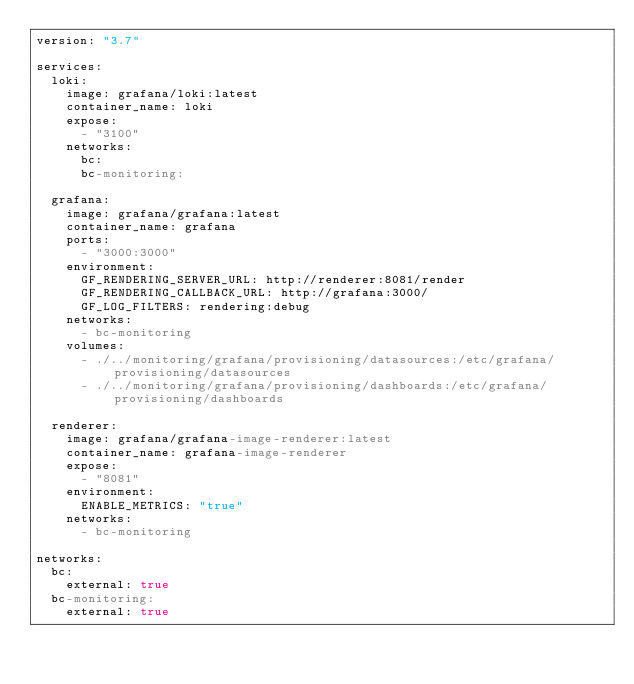Convert code to text. <code><loc_0><loc_0><loc_500><loc_500><_YAML_>version: "3.7"

services:
  loki:
    image: grafana/loki:latest
    container_name: loki
    expose:
      - "3100"
    networks:
      bc:
      bc-monitoring:

  grafana:
    image: grafana/grafana:latest
    container_name: grafana
    ports:
      - "3000:3000"
    environment:
      GF_RENDERING_SERVER_URL: http://renderer:8081/render
      GF_RENDERING_CALLBACK_URL: http://grafana:3000/
      GF_LOG_FILTERS: rendering:debug
    networks:
      - bc-monitoring
    volumes:
      - ./../monitoring/grafana/provisioning/datasources:/etc/grafana/provisioning/datasources
      - ./../monitoring/grafana/provisioning/dashboards:/etc/grafana/provisioning/dashboards

  renderer:
    image: grafana/grafana-image-renderer:latest
    container_name: grafana-image-renderer
    expose:
      - "8081"
    environment:
      ENABLE_METRICS: "true"
    networks:
      - bc-monitoring

networks:
  bc:
    external: true
  bc-monitoring:
    external: true
</code> 